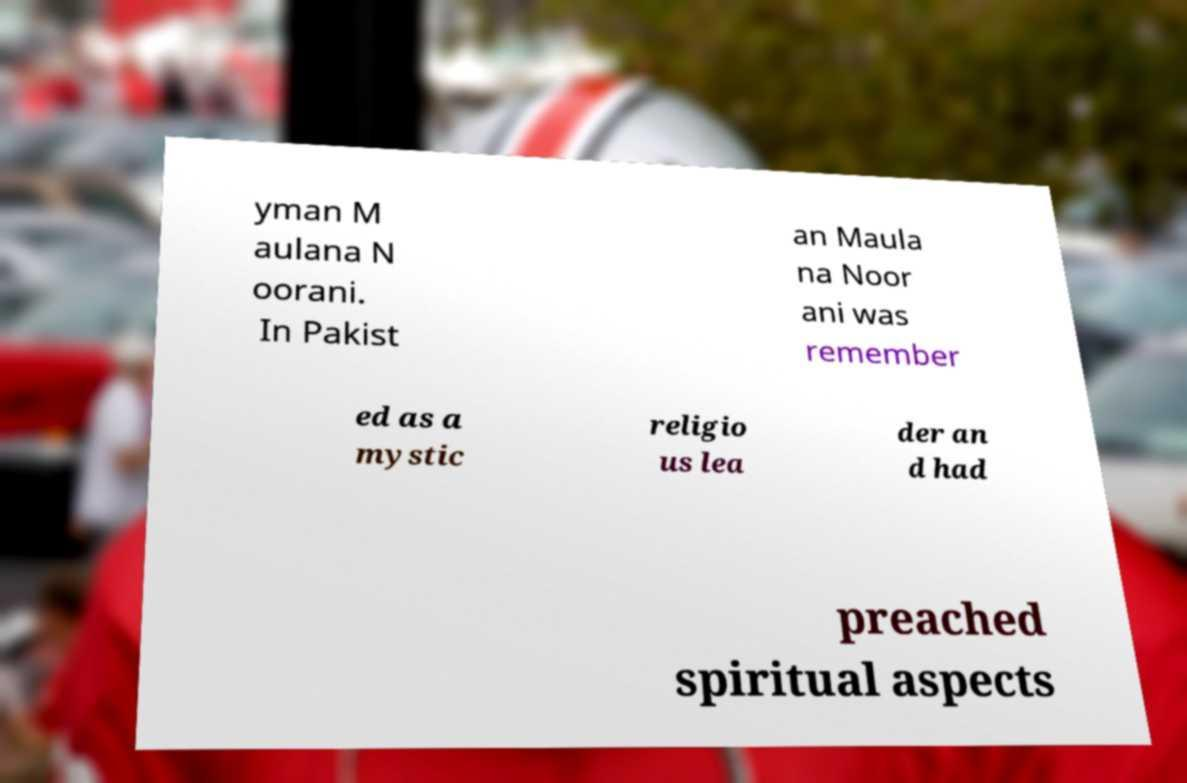Please read and relay the text visible in this image. What does it say? yman M aulana N oorani. In Pakist an Maula na Noor ani was remember ed as a mystic religio us lea der an d had preached spiritual aspects 